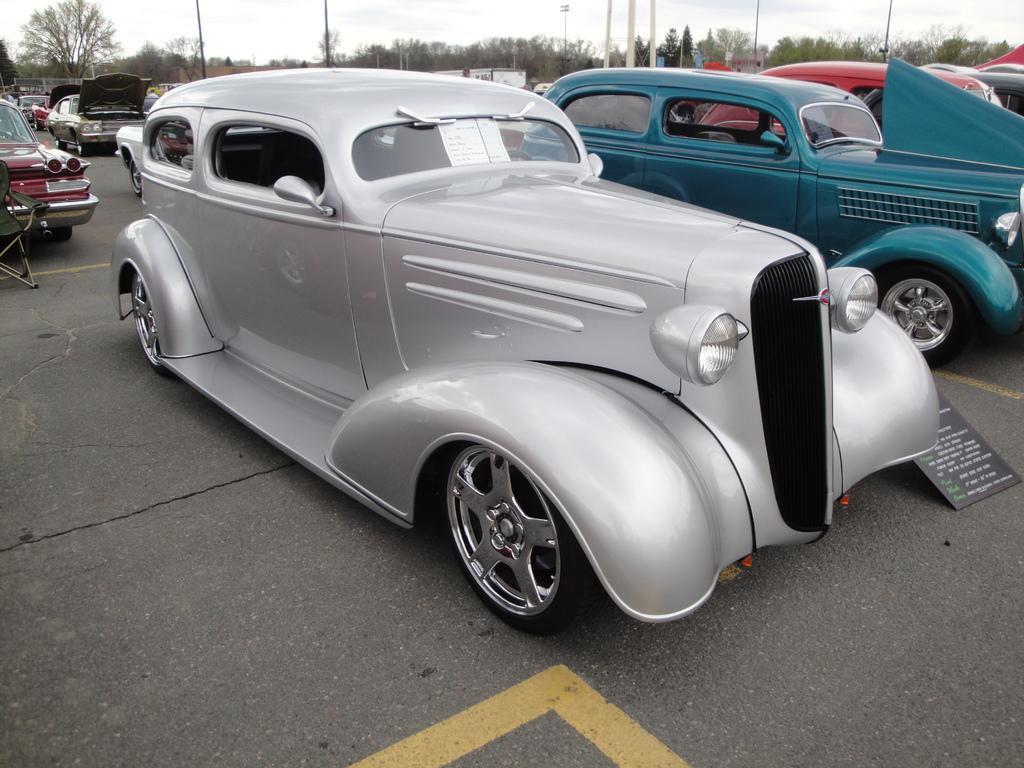Could you give a brief overview of what you see in this image? In this image there are a group of vehicles, and in the background there are some tees, poles and some houses. At the bottom there is a road and on the right side there is some board, on the board there is some text. 